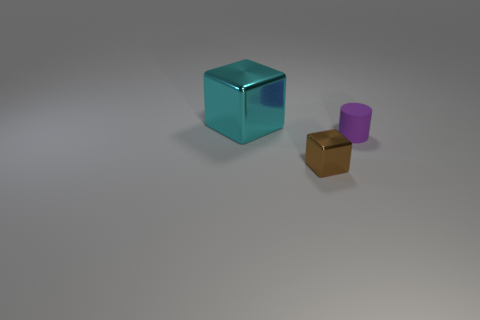Add 3 blue spheres. How many objects exist? 6 Subtract all blocks. How many objects are left? 1 Add 1 large green matte blocks. How many large green matte blocks exist? 1 Subtract 0 purple cubes. How many objects are left? 3 Subtract all big objects. Subtract all large gray metallic balls. How many objects are left? 2 Add 1 tiny brown things. How many tiny brown things are left? 2 